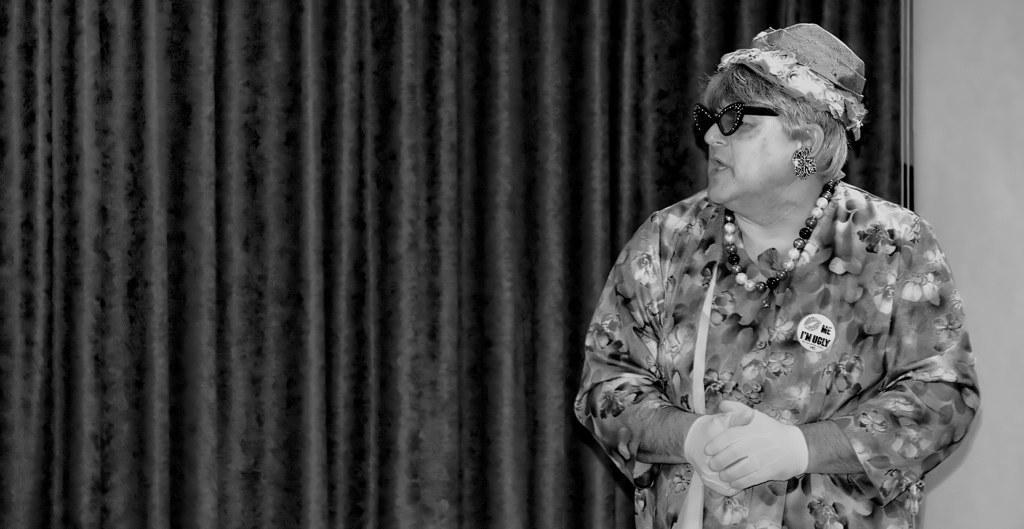How would you summarize this image in a sentence or two? In the image we can see there is a person standing and there is a badge on the person´s jacket. The person is wearing beads necklace, sunglasses and hat. Behind there is a curtain and the image is in black and white colour. 